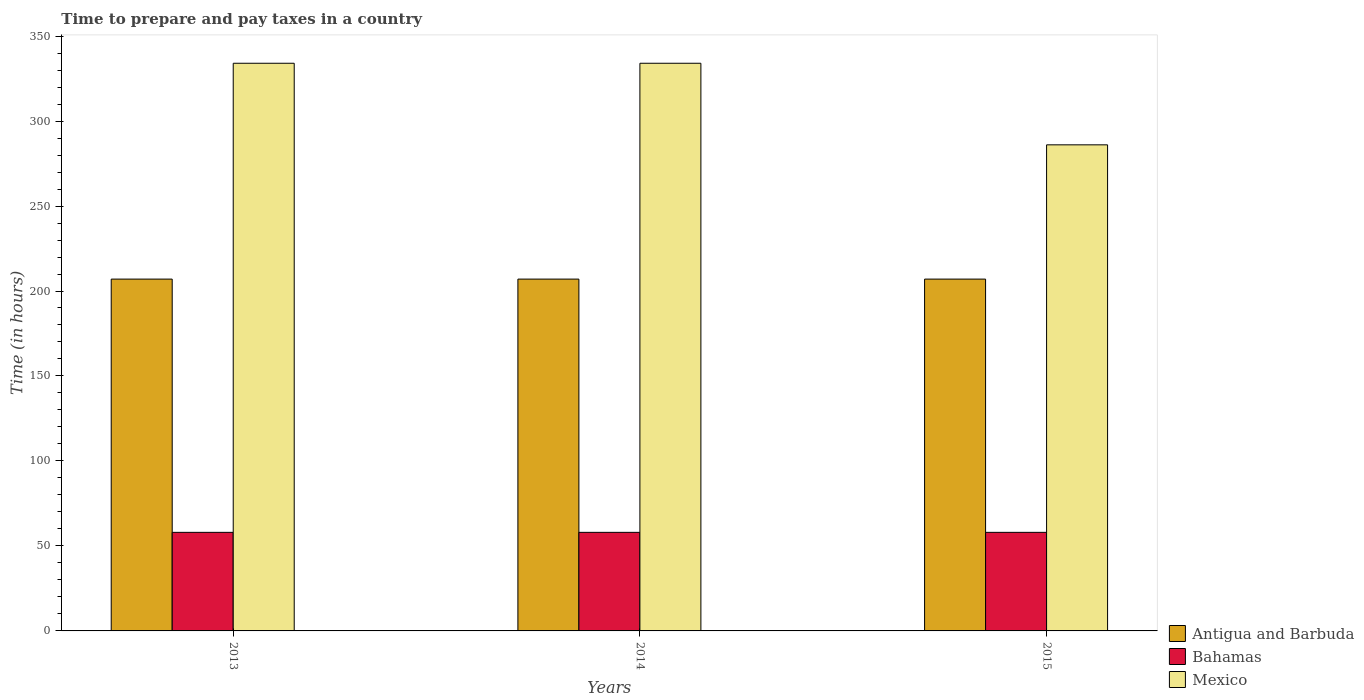How many different coloured bars are there?
Make the answer very short. 3. How many groups of bars are there?
Your response must be concise. 3. Are the number of bars per tick equal to the number of legend labels?
Ensure brevity in your answer.  Yes. Are the number of bars on each tick of the X-axis equal?
Provide a short and direct response. Yes. What is the label of the 1st group of bars from the left?
Give a very brief answer. 2013. In how many cases, is the number of bars for a given year not equal to the number of legend labels?
Provide a short and direct response. 0. What is the number of hours required to prepare and pay taxes in Mexico in 2014?
Your answer should be very brief. 334. Across all years, what is the maximum number of hours required to prepare and pay taxes in Mexico?
Offer a terse response. 334. Across all years, what is the minimum number of hours required to prepare and pay taxes in Antigua and Barbuda?
Provide a short and direct response. 207. In which year was the number of hours required to prepare and pay taxes in Bahamas minimum?
Ensure brevity in your answer.  2013. What is the total number of hours required to prepare and pay taxes in Antigua and Barbuda in the graph?
Provide a short and direct response. 621. What is the difference between the number of hours required to prepare and pay taxes in Antigua and Barbuda in 2015 and the number of hours required to prepare and pay taxes in Bahamas in 2013?
Provide a succinct answer. 149. What is the average number of hours required to prepare and pay taxes in Mexico per year?
Provide a short and direct response. 318. In the year 2014, what is the difference between the number of hours required to prepare and pay taxes in Antigua and Barbuda and number of hours required to prepare and pay taxes in Mexico?
Your answer should be compact. -127. Is the difference between the number of hours required to prepare and pay taxes in Antigua and Barbuda in 2013 and 2014 greater than the difference between the number of hours required to prepare and pay taxes in Mexico in 2013 and 2014?
Provide a short and direct response. No. In how many years, is the number of hours required to prepare and pay taxes in Antigua and Barbuda greater than the average number of hours required to prepare and pay taxes in Antigua and Barbuda taken over all years?
Your response must be concise. 0. What does the 3rd bar from the left in 2015 represents?
Keep it short and to the point. Mexico. What does the 2nd bar from the right in 2015 represents?
Offer a very short reply. Bahamas. How many bars are there?
Your answer should be compact. 9. How many years are there in the graph?
Keep it short and to the point. 3. What is the difference between two consecutive major ticks on the Y-axis?
Make the answer very short. 50. Does the graph contain any zero values?
Provide a succinct answer. No. Does the graph contain grids?
Give a very brief answer. No. Where does the legend appear in the graph?
Give a very brief answer. Bottom right. What is the title of the graph?
Provide a succinct answer. Time to prepare and pay taxes in a country. Does "Central Europe" appear as one of the legend labels in the graph?
Your answer should be compact. No. What is the label or title of the Y-axis?
Your response must be concise. Time (in hours). What is the Time (in hours) of Antigua and Barbuda in 2013?
Your answer should be very brief. 207. What is the Time (in hours) in Mexico in 2013?
Your response must be concise. 334. What is the Time (in hours) of Antigua and Barbuda in 2014?
Provide a succinct answer. 207. What is the Time (in hours) of Bahamas in 2014?
Your response must be concise. 58. What is the Time (in hours) in Mexico in 2014?
Ensure brevity in your answer.  334. What is the Time (in hours) of Antigua and Barbuda in 2015?
Provide a short and direct response. 207. What is the Time (in hours) in Bahamas in 2015?
Make the answer very short. 58. What is the Time (in hours) of Mexico in 2015?
Your answer should be compact. 286. Across all years, what is the maximum Time (in hours) in Antigua and Barbuda?
Ensure brevity in your answer.  207. Across all years, what is the maximum Time (in hours) in Mexico?
Give a very brief answer. 334. Across all years, what is the minimum Time (in hours) of Antigua and Barbuda?
Keep it short and to the point. 207. Across all years, what is the minimum Time (in hours) of Bahamas?
Make the answer very short. 58. Across all years, what is the minimum Time (in hours) in Mexico?
Your answer should be very brief. 286. What is the total Time (in hours) in Antigua and Barbuda in the graph?
Ensure brevity in your answer.  621. What is the total Time (in hours) in Bahamas in the graph?
Offer a very short reply. 174. What is the total Time (in hours) in Mexico in the graph?
Make the answer very short. 954. What is the difference between the Time (in hours) in Mexico in 2013 and that in 2014?
Offer a terse response. 0. What is the difference between the Time (in hours) in Bahamas in 2014 and that in 2015?
Your answer should be compact. 0. What is the difference between the Time (in hours) in Mexico in 2014 and that in 2015?
Your answer should be compact. 48. What is the difference between the Time (in hours) of Antigua and Barbuda in 2013 and the Time (in hours) of Bahamas in 2014?
Offer a very short reply. 149. What is the difference between the Time (in hours) in Antigua and Barbuda in 2013 and the Time (in hours) in Mexico in 2014?
Give a very brief answer. -127. What is the difference between the Time (in hours) of Bahamas in 2013 and the Time (in hours) of Mexico in 2014?
Give a very brief answer. -276. What is the difference between the Time (in hours) of Antigua and Barbuda in 2013 and the Time (in hours) of Bahamas in 2015?
Provide a short and direct response. 149. What is the difference between the Time (in hours) in Antigua and Barbuda in 2013 and the Time (in hours) in Mexico in 2015?
Offer a very short reply. -79. What is the difference between the Time (in hours) in Bahamas in 2013 and the Time (in hours) in Mexico in 2015?
Offer a very short reply. -228. What is the difference between the Time (in hours) in Antigua and Barbuda in 2014 and the Time (in hours) in Bahamas in 2015?
Keep it short and to the point. 149. What is the difference between the Time (in hours) of Antigua and Barbuda in 2014 and the Time (in hours) of Mexico in 2015?
Provide a short and direct response. -79. What is the difference between the Time (in hours) in Bahamas in 2014 and the Time (in hours) in Mexico in 2015?
Your response must be concise. -228. What is the average Time (in hours) in Antigua and Barbuda per year?
Give a very brief answer. 207. What is the average Time (in hours) of Bahamas per year?
Make the answer very short. 58. What is the average Time (in hours) in Mexico per year?
Ensure brevity in your answer.  318. In the year 2013, what is the difference between the Time (in hours) in Antigua and Barbuda and Time (in hours) in Bahamas?
Offer a terse response. 149. In the year 2013, what is the difference between the Time (in hours) of Antigua and Barbuda and Time (in hours) of Mexico?
Provide a short and direct response. -127. In the year 2013, what is the difference between the Time (in hours) in Bahamas and Time (in hours) in Mexico?
Make the answer very short. -276. In the year 2014, what is the difference between the Time (in hours) of Antigua and Barbuda and Time (in hours) of Bahamas?
Give a very brief answer. 149. In the year 2014, what is the difference between the Time (in hours) of Antigua and Barbuda and Time (in hours) of Mexico?
Give a very brief answer. -127. In the year 2014, what is the difference between the Time (in hours) of Bahamas and Time (in hours) of Mexico?
Make the answer very short. -276. In the year 2015, what is the difference between the Time (in hours) in Antigua and Barbuda and Time (in hours) in Bahamas?
Offer a very short reply. 149. In the year 2015, what is the difference between the Time (in hours) of Antigua and Barbuda and Time (in hours) of Mexico?
Keep it short and to the point. -79. In the year 2015, what is the difference between the Time (in hours) of Bahamas and Time (in hours) of Mexico?
Ensure brevity in your answer.  -228. What is the ratio of the Time (in hours) in Antigua and Barbuda in 2013 to that in 2014?
Make the answer very short. 1. What is the ratio of the Time (in hours) in Antigua and Barbuda in 2013 to that in 2015?
Offer a terse response. 1. What is the ratio of the Time (in hours) of Mexico in 2013 to that in 2015?
Offer a terse response. 1.17. What is the ratio of the Time (in hours) of Bahamas in 2014 to that in 2015?
Keep it short and to the point. 1. What is the ratio of the Time (in hours) of Mexico in 2014 to that in 2015?
Ensure brevity in your answer.  1.17. What is the difference between the highest and the second highest Time (in hours) in Mexico?
Your response must be concise. 0. 